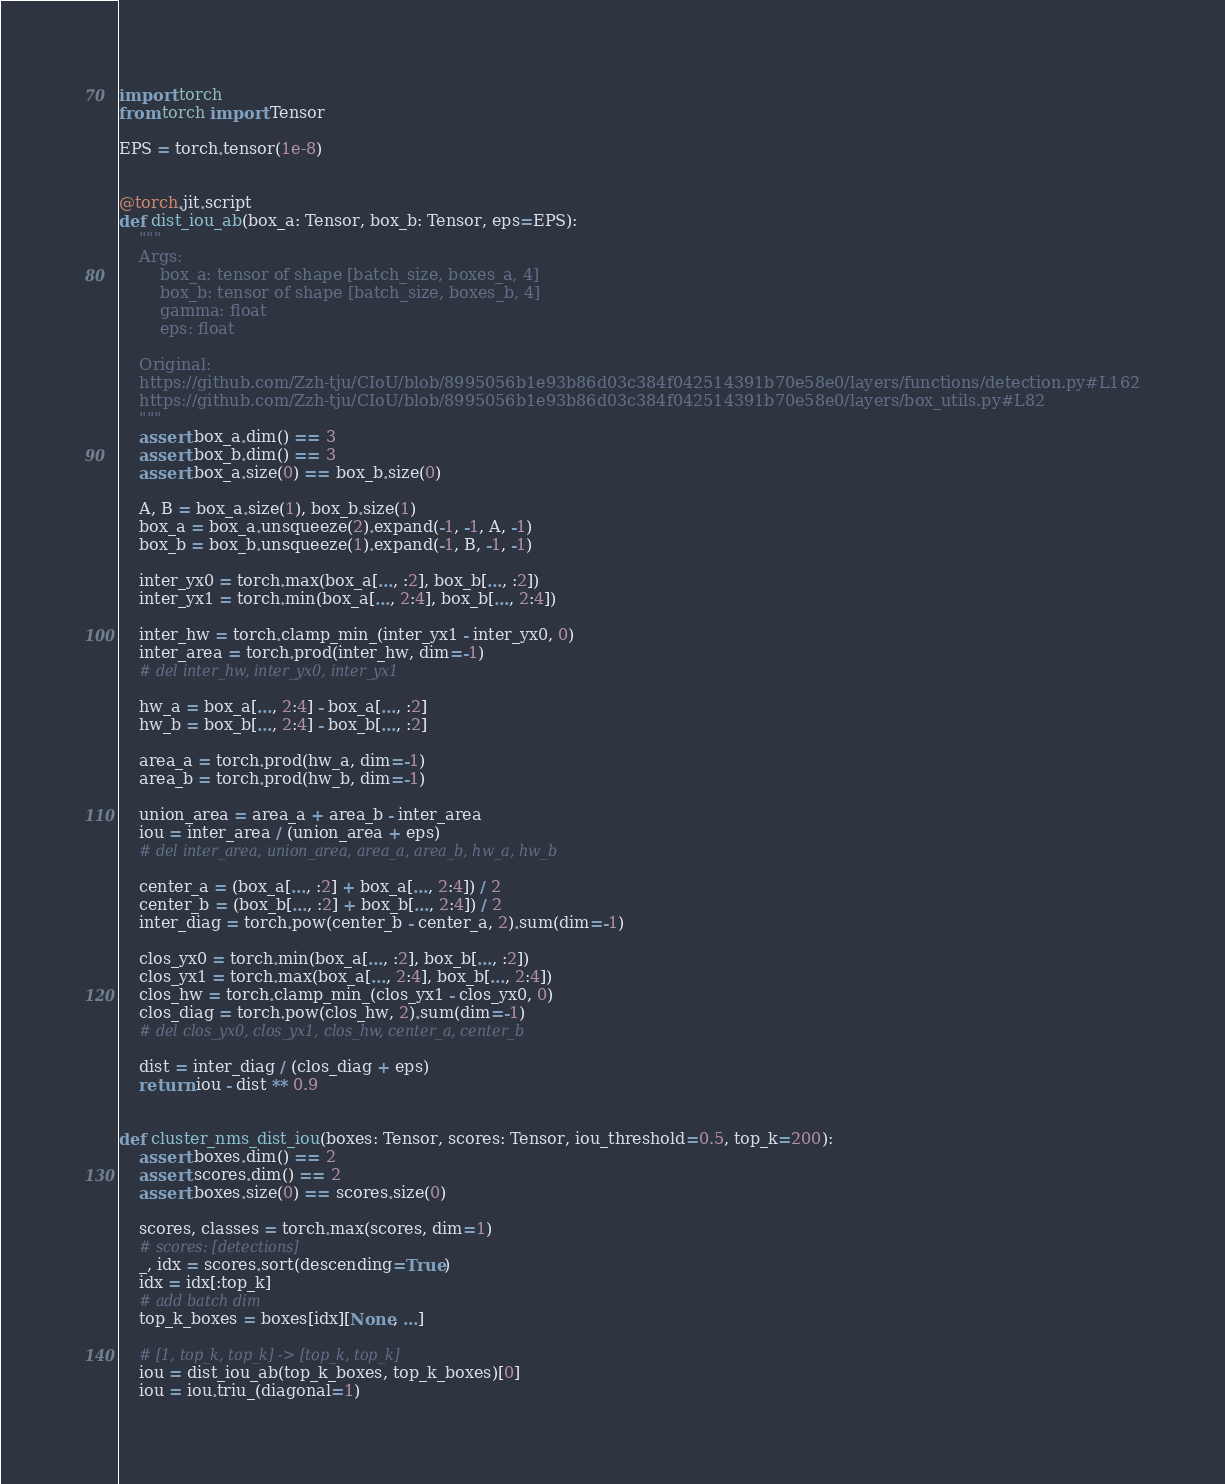<code> <loc_0><loc_0><loc_500><loc_500><_Python_>import torch
from torch import Tensor

EPS = torch.tensor(1e-8)


@torch.jit.script
def dist_iou_ab(box_a: Tensor, box_b: Tensor, eps=EPS):
    """
    Args:
        box_a: tensor of shape [batch_size, boxes_a, 4]
        box_b: tensor of shape [batch_size, boxes_b, 4]
        gamma: float
        eps: float

    Original:
    https://github.com/Zzh-tju/CIoU/blob/8995056b1e93b86d03c384f042514391b70e58e0/layers/functions/detection.py#L162
    https://github.com/Zzh-tju/CIoU/blob/8995056b1e93b86d03c384f042514391b70e58e0/layers/box_utils.py#L82
    """
    assert box_a.dim() == 3
    assert box_b.dim() == 3
    assert box_a.size(0) == box_b.size(0)

    A, B = box_a.size(1), box_b.size(1)
    box_a = box_a.unsqueeze(2).expand(-1, -1, A, -1)
    box_b = box_b.unsqueeze(1).expand(-1, B, -1, -1)

    inter_yx0 = torch.max(box_a[..., :2], box_b[..., :2])
    inter_yx1 = torch.min(box_a[..., 2:4], box_b[..., 2:4])

    inter_hw = torch.clamp_min_(inter_yx1 - inter_yx0, 0)
    inter_area = torch.prod(inter_hw, dim=-1)
    # del inter_hw, inter_yx0, inter_yx1

    hw_a = box_a[..., 2:4] - box_a[..., :2]
    hw_b = box_b[..., 2:4] - box_b[..., :2]

    area_a = torch.prod(hw_a, dim=-1)
    area_b = torch.prod(hw_b, dim=-1)

    union_area = area_a + area_b - inter_area
    iou = inter_area / (union_area + eps)
    # del inter_area, union_area, area_a, area_b, hw_a, hw_b

    center_a = (box_a[..., :2] + box_a[..., 2:4]) / 2
    center_b = (box_b[..., :2] + box_b[..., 2:4]) / 2
    inter_diag = torch.pow(center_b - center_a, 2).sum(dim=-1)

    clos_yx0 = torch.min(box_a[..., :2], box_b[..., :2])
    clos_yx1 = torch.max(box_a[..., 2:4], box_b[..., 2:4])
    clos_hw = torch.clamp_min_(clos_yx1 - clos_yx0, 0)
    clos_diag = torch.pow(clos_hw, 2).sum(dim=-1)
    # del clos_yx0, clos_yx1, clos_hw, center_a, center_b

    dist = inter_diag / (clos_diag + eps)
    return iou - dist ** 0.9


def cluster_nms_dist_iou(boxes: Tensor, scores: Tensor, iou_threshold=0.5, top_k=200):
    assert boxes.dim() == 2
    assert scores.dim() == 2
    assert boxes.size(0) == scores.size(0)

    scores, classes = torch.max(scores, dim=1)
    # scores: [detections]
    _, idx = scores.sort(descending=True)
    idx = idx[:top_k]
    # add batch dim
    top_k_boxes = boxes[idx][None, ...]

    # [1, top_k, top_k] -> [top_k, top_k]
    iou = dist_iou_ab(top_k_boxes, top_k_boxes)[0]
    iou = iou.triu_(diagonal=1)</code> 